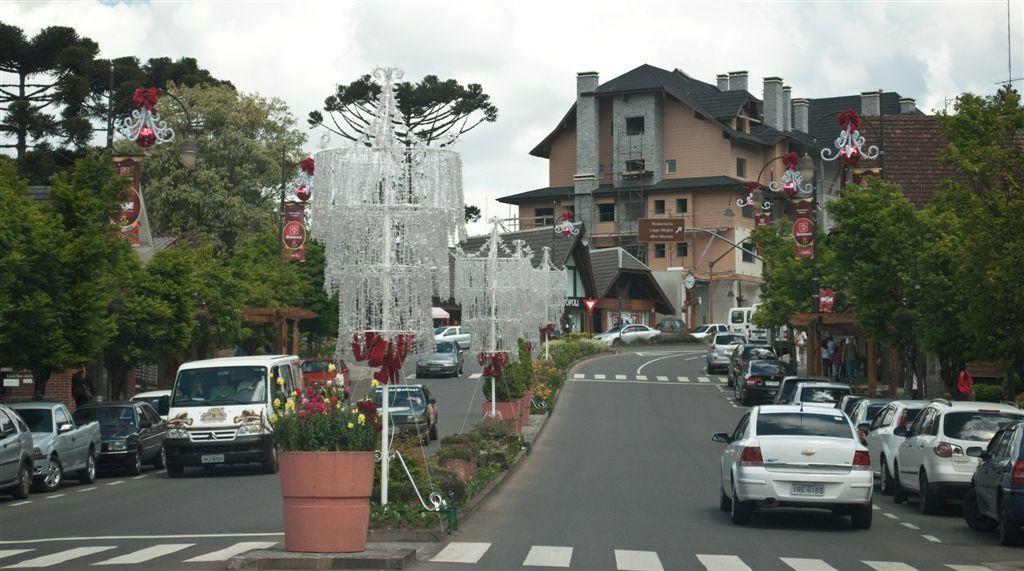Describe this image in one or two sentences. In this image we can see group of vehicles parked on the road. In the foreground of the image we can see flowering plants in a container. In the middle of the image we can see a group of poles. In the background we can see a group of buildings, trees and sky. 